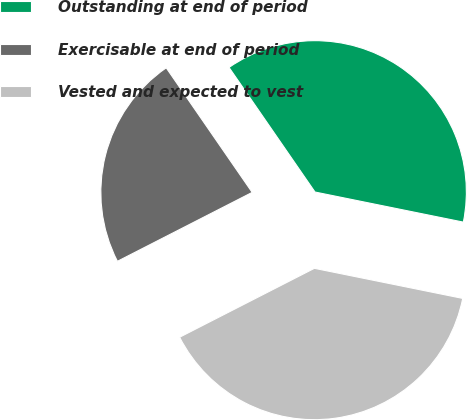Convert chart. <chart><loc_0><loc_0><loc_500><loc_500><pie_chart><fcel>Outstanding at end of period<fcel>Exercisable at end of period<fcel>Vested and expected to vest<nl><fcel>37.8%<fcel>22.91%<fcel>39.29%<nl></chart> 